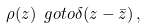Convert formula to latex. <formula><loc_0><loc_0><loc_500><loc_500>\rho ( z ) \ g o t o \delta ( z - \bar { z } ) \, ,</formula> 